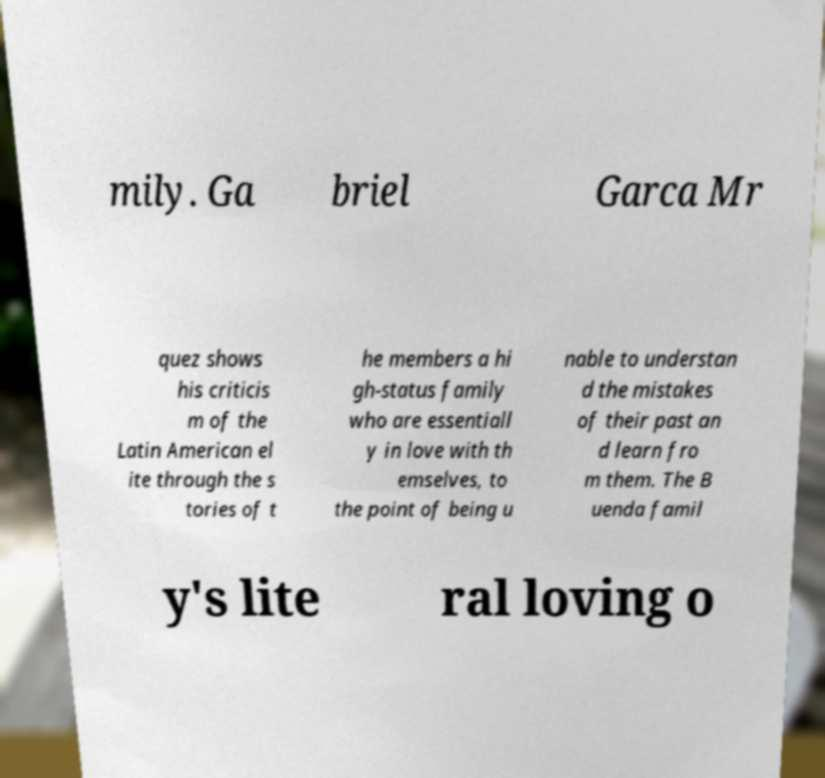Please read and relay the text visible in this image. What does it say? mily. Ga briel Garca Mr quez shows his criticis m of the Latin American el ite through the s tories of t he members a hi gh-status family who are essentiall y in love with th emselves, to the point of being u nable to understan d the mistakes of their past an d learn fro m them. The B uenda famil y's lite ral loving o 